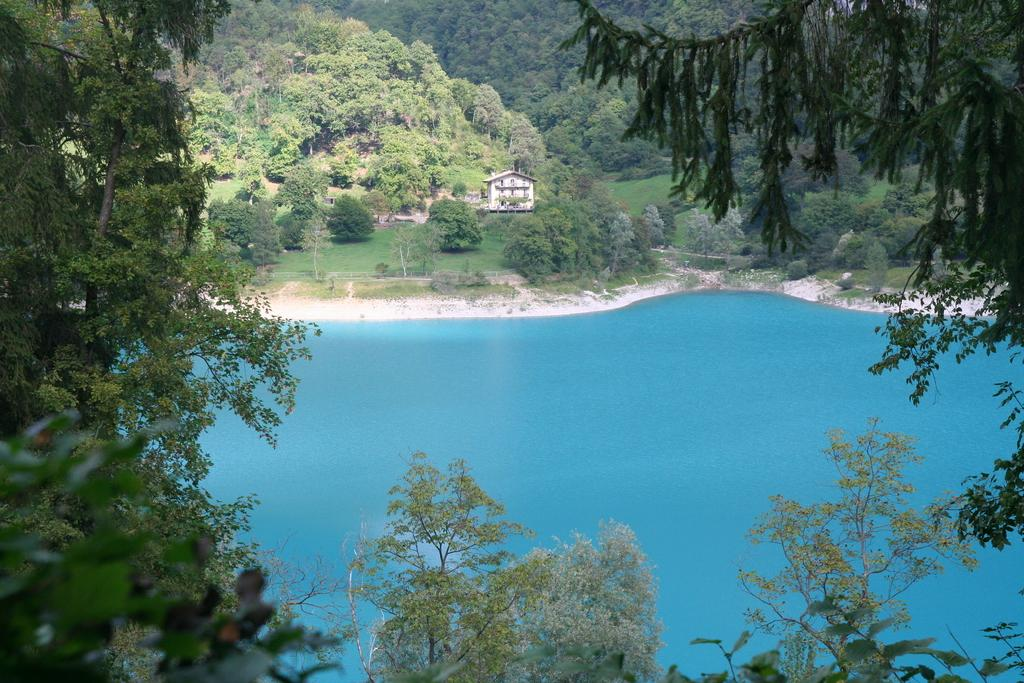What type of vegetation can be seen in the image? There are trees in the image. What natural element is visible in the image? There is water visible in the image. What type of structure can be seen in the background of the image? There is a house in the background of the image. What type of ornament is hanging from the trees in the image? There are no ornaments present in the image; it features trees and water. How many hammers can be seen in the image? There are no hammers present in the image. 